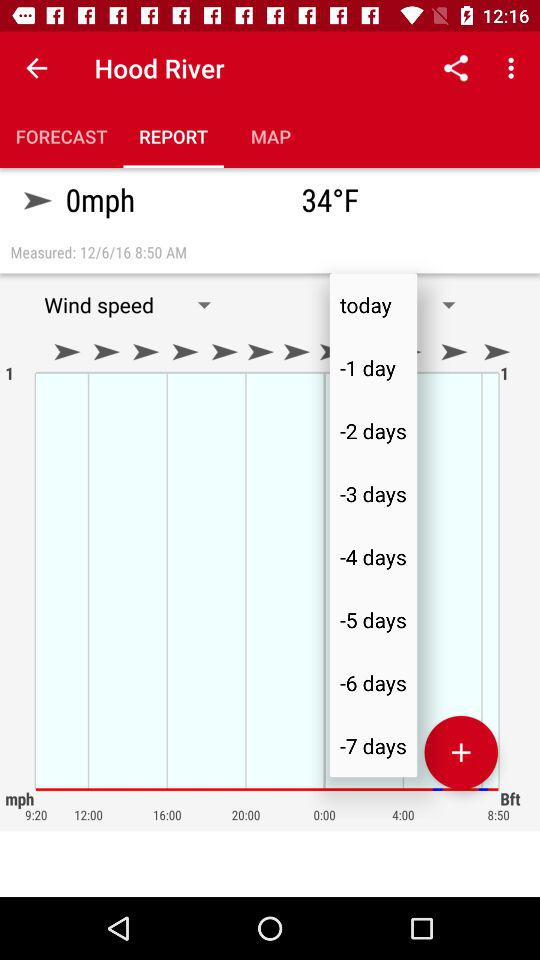What is the temperature on the screen? The temperature on the screen is 34 °F. 